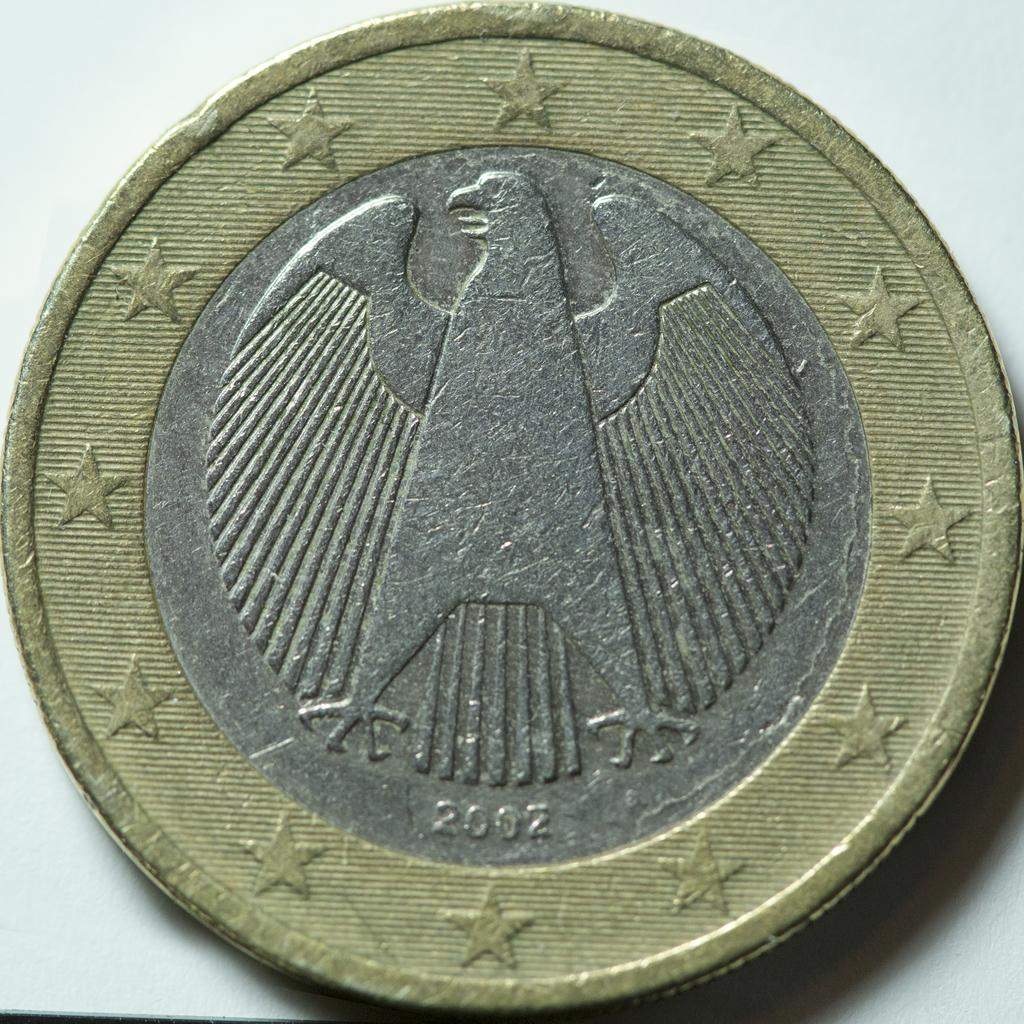<image>
Relay a brief, clear account of the picture shown. A gold and silvere coin shows an eagle, the coin is from 2002 